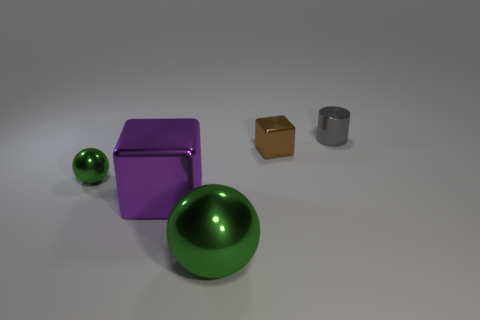Add 5 tiny metallic things. How many objects exist? 10 Subtract all cylinders. How many objects are left? 4 Subtract all brown cubes. How many cyan balls are left? 0 Subtract all tiny red metal cylinders. Subtract all green metal balls. How many objects are left? 3 Add 3 balls. How many balls are left? 5 Add 1 big purple metal cubes. How many big purple metal cubes exist? 2 Subtract 0 blue spheres. How many objects are left? 5 Subtract 1 cubes. How many cubes are left? 1 Subtract all red cubes. Subtract all purple cylinders. How many cubes are left? 2 